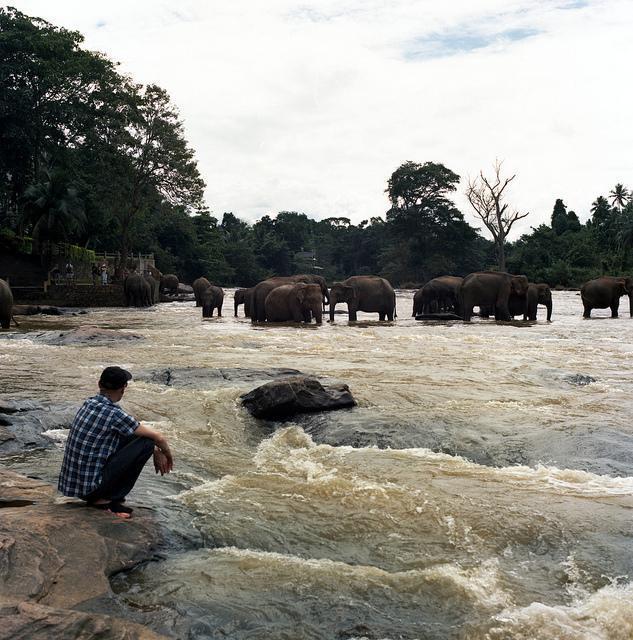How many elephants are there?
Give a very brief answer. 2. How many people can you see?
Give a very brief answer. 1. 